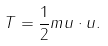Convert formula to latex. <formula><loc_0><loc_0><loc_500><loc_500>T = \frac { 1 } { 2 } m { u } \cdot { u } .</formula> 